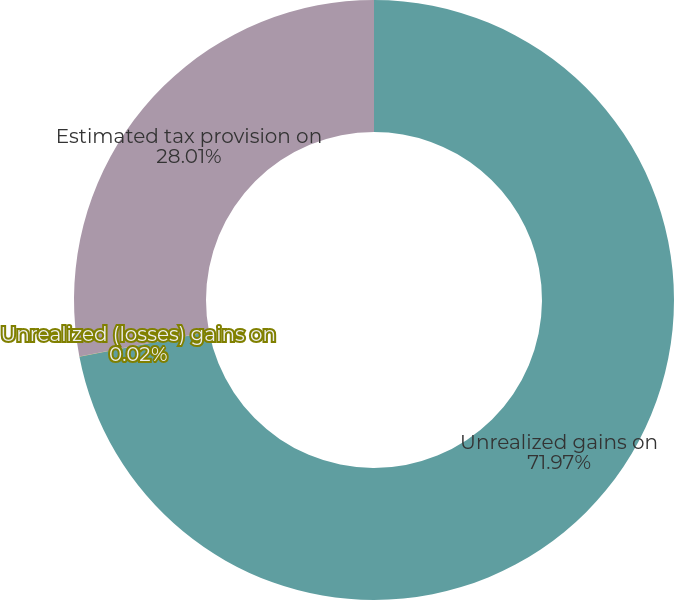Convert chart to OTSL. <chart><loc_0><loc_0><loc_500><loc_500><pie_chart><fcel>Unrealized gains on<fcel>Unrealized (losses) gains on<fcel>Estimated tax provision on<nl><fcel>71.97%<fcel>0.02%<fcel>28.01%<nl></chart> 